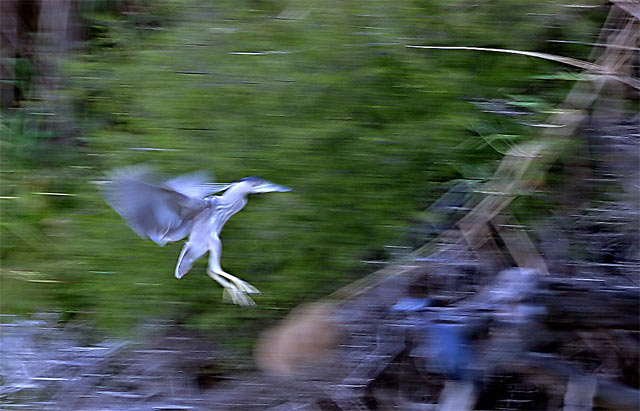Is the lighting weak in the image? The lighting in the image appears to be of moderate intensity, with sufficient light to highlight the subject, which is a bird in motion, against the blurred background. The dynamic quality of the photograph suggests that it might have been taken in natural light conditions, leading to areas of variable brightness. 